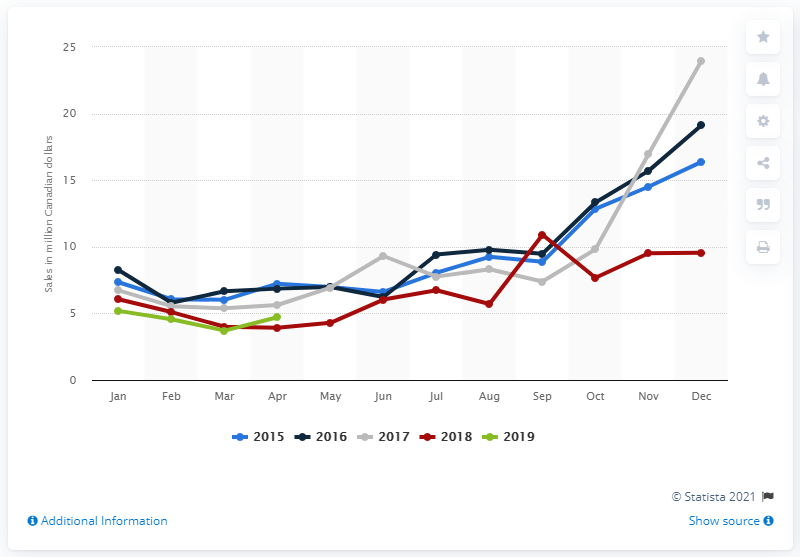Highlight a few significant elements in this photo. In April 2019, a total of 4.71 Canadian dollars were spent on unisex clothing and accessories at large retailers. In April 2019, a total of 4.71 Canadian dollars were spent on unisex clothing and accessories at large retailers. 